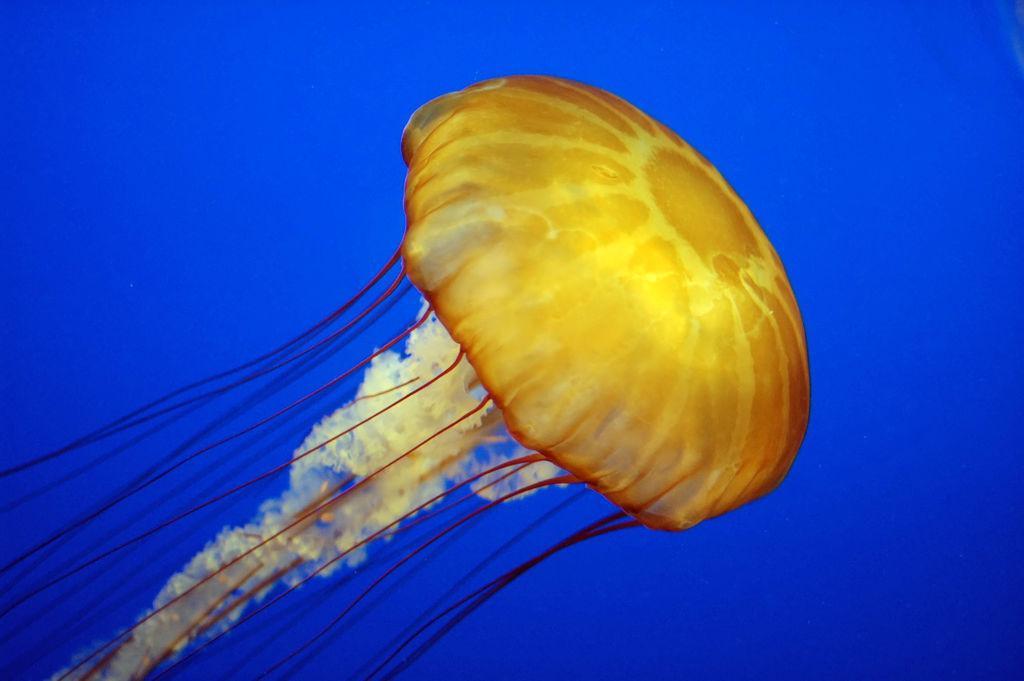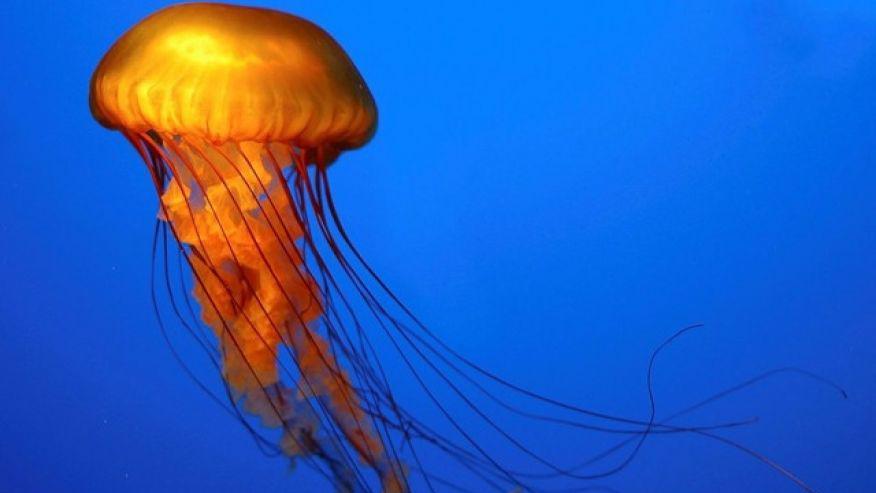The first image is the image on the left, the second image is the image on the right. For the images shown, is this caption "The right-hand jellyfish appears tilted down, with its """"cap"""" going  rightward." true? Answer yes or no. No. 